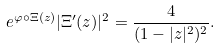Convert formula to latex. <formula><loc_0><loc_0><loc_500><loc_500>e ^ { \varphi \circ \Xi ( z ) } | \Xi ^ { \prime } ( z ) | ^ { 2 } = \frac { 4 } { ( 1 - | z | ^ { 2 } ) ^ { 2 } } .</formula> 